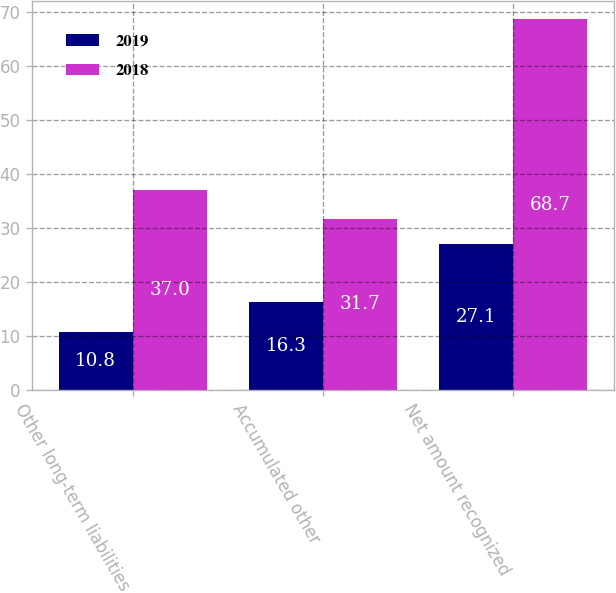Convert chart. <chart><loc_0><loc_0><loc_500><loc_500><stacked_bar_chart><ecel><fcel>Other long-term liabilities<fcel>Accumulated other<fcel>Net amount recognized<nl><fcel>2019<fcel>10.8<fcel>16.3<fcel>27.1<nl><fcel>2018<fcel>37<fcel>31.7<fcel>68.7<nl></chart> 